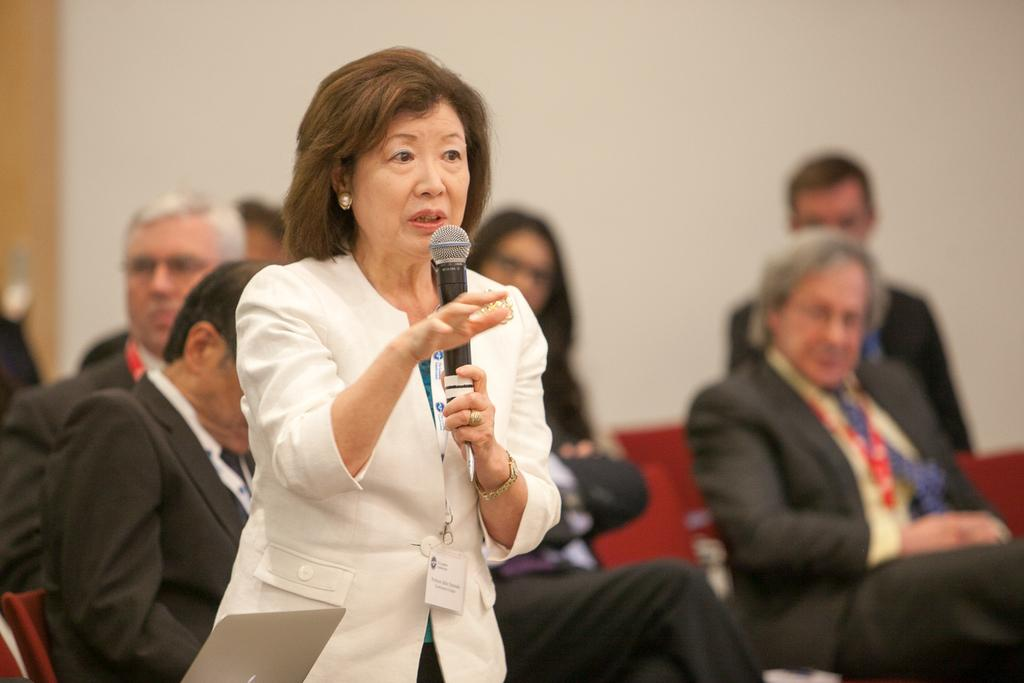What is the primary subject of the image? There is a woman in the image. What is the woman doing in the image? The woman is standing and speaking into a microphone. What can be observed about the people in the image? There are people seated in the image, and they are seated on chairs. What type of fish can be seen swimming in the microphone in the image? There are no fish present in the image, and the microphone is not a body of water where fish could swim. 